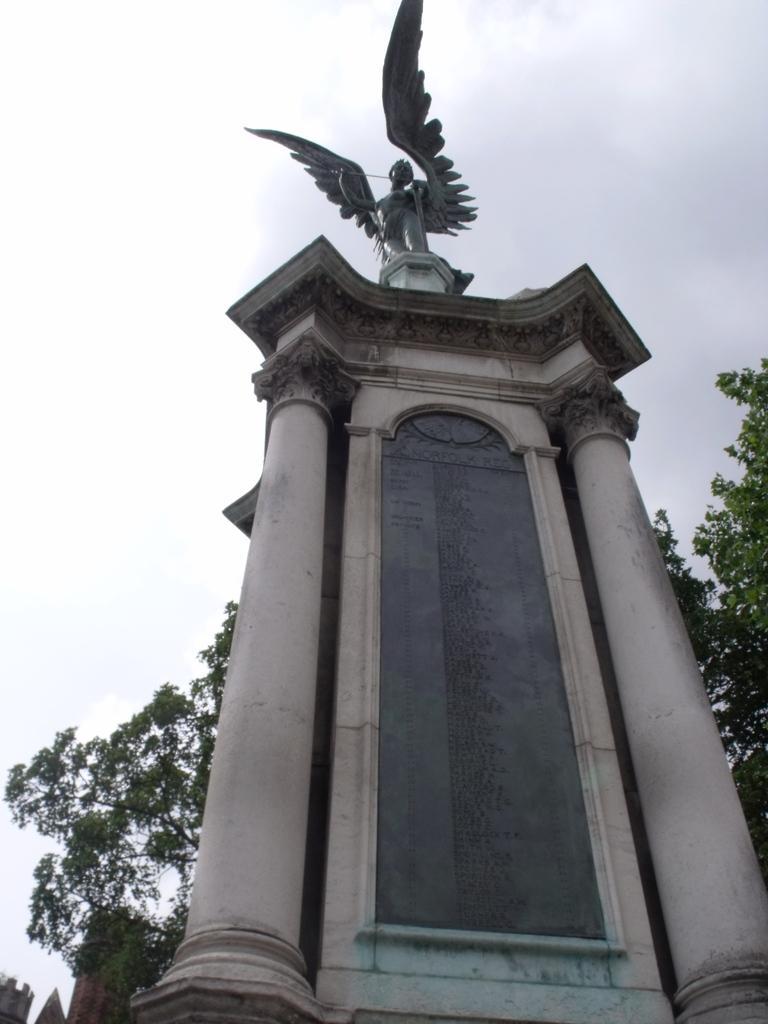How would you summarize this image in a sentence or two? In this picture there is a stone structure on the right side of the image, on which there is a statue and there are trees in the background area of the image. 